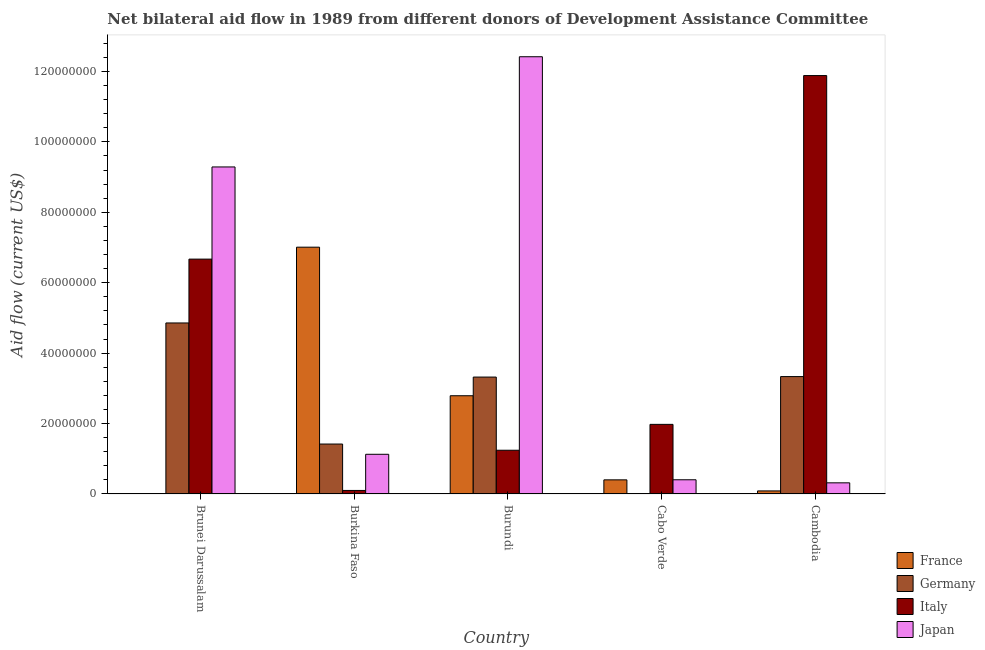Are the number of bars per tick equal to the number of legend labels?
Ensure brevity in your answer.  Yes. Are the number of bars on each tick of the X-axis equal?
Your response must be concise. Yes. What is the label of the 5th group of bars from the left?
Provide a succinct answer. Cambodia. In how many cases, is the number of bars for a given country not equal to the number of legend labels?
Keep it short and to the point. 0. What is the amount of aid given by japan in Cabo Verde?
Your answer should be compact. 4.03e+06. Across all countries, what is the maximum amount of aid given by germany?
Provide a succinct answer. 4.86e+07. Across all countries, what is the minimum amount of aid given by japan?
Offer a terse response. 3.16e+06. In which country was the amount of aid given by france maximum?
Your response must be concise. Burkina Faso. In which country was the amount of aid given by germany minimum?
Keep it short and to the point. Cabo Verde. What is the total amount of aid given by japan in the graph?
Give a very brief answer. 2.36e+08. What is the difference between the amount of aid given by germany in Brunei Darussalam and that in Burkina Faso?
Make the answer very short. 3.44e+07. What is the difference between the amount of aid given by france in Brunei Darussalam and the amount of aid given by italy in Burkina Faso?
Provide a short and direct response. -8.70e+05. What is the average amount of aid given by japan per country?
Your answer should be compact. 4.71e+07. What is the difference between the amount of aid given by france and amount of aid given by germany in Cabo Verde?
Ensure brevity in your answer.  3.97e+06. In how many countries, is the amount of aid given by japan greater than 124000000 US$?
Your answer should be compact. 1. What is the ratio of the amount of aid given by france in Burkina Faso to that in Burundi?
Make the answer very short. 2.51. Is the amount of aid given by italy in Brunei Darussalam less than that in Burundi?
Keep it short and to the point. No. What is the difference between the highest and the second highest amount of aid given by germany?
Give a very brief answer. 1.52e+07. What is the difference between the highest and the lowest amount of aid given by france?
Provide a succinct answer. 7.00e+07. In how many countries, is the amount of aid given by germany greater than the average amount of aid given by germany taken over all countries?
Offer a terse response. 3. Is it the case that in every country, the sum of the amount of aid given by italy and amount of aid given by japan is greater than the sum of amount of aid given by germany and amount of aid given by france?
Provide a succinct answer. Yes. What does the 3rd bar from the left in Burundi represents?
Make the answer very short. Italy. What does the 2nd bar from the right in Burundi represents?
Provide a short and direct response. Italy. Is it the case that in every country, the sum of the amount of aid given by france and amount of aid given by germany is greater than the amount of aid given by italy?
Make the answer very short. No. How many bars are there?
Provide a short and direct response. 20. What is the difference between two consecutive major ticks on the Y-axis?
Provide a short and direct response. 2.00e+07. Are the values on the major ticks of Y-axis written in scientific E-notation?
Give a very brief answer. No. Does the graph contain any zero values?
Provide a short and direct response. No. Where does the legend appear in the graph?
Your answer should be very brief. Bottom right. What is the title of the graph?
Offer a terse response. Net bilateral aid flow in 1989 from different donors of Development Assistance Committee. What is the label or title of the X-axis?
Your answer should be very brief. Country. What is the label or title of the Y-axis?
Give a very brief answer. Aid flow (current US$). What is the Aid flow (current US$) of France in Brunei Darussalam?
Provide a succinct answer. 1.30e+05. What is the Aid flow (current US$) in Germany in Brunei Darussalam?
Your response must be concise. 4.86e+07. What is the Aid flow (current US$) of Italy in Brunei Darussalam?
Give a very brief answer. 6.67e+07. What is the Aid flow (current US$) in Japan in Brunei Darussalam?
Provide a short and direct response. 9.29e+07. What is the Aid flow (current US$) in France in Burkina Faso?
Your answer should be compact. 7.01e+07. What is the Aid flow (current US$) of Germany in Burkina Faso?
Your answer should be compact. 1.42e+07. What is the Aid flow (current US$) of Japan in Burkina Faso?
Offer a very short reply. 1.13e+07. What is the Aid flow (current US$) of France in Burundi?
Keep it short and to the point. 2.79e+07. What is the Aid flow (current US$) of Germany in Burundi?
Give a very brief answer. 3.32e+07. What is the Aid flow (current US$) of Italy in Burundi?
Make the answer very short. 1.24e+07. What is the Aid flow (current US$) in Japan in Burundi?
Keep it short and to the point. 1.24e+08. What is the Aid flow (current US$) of France in Cabo Verde?
Offer a terse response. 4.01e+06. What is the Aid flow (current US$) of Germany in Cabo Verde?
Your answer should be very brief. 4.00e+04. What is the Aid flow (current US$) of Italy in Cabo Verde?
Provide a succinct answer. 1.98e+07. What is the Aid flow (current US$) of Japan in Cabo Verde?
Your response must be concise. 4.03e+06. What is the Aid flow (current US$) in France in Cambodia?
Make the answer very short. 8.70e+05. What is the Aid flow (current US$) in Germany in Cambodia?
Your response must be concise. 3.33e+07. What is the Aid flow (current US$) of Italy in Cambodia?
Ensure brevity in your answer.  1.19e+08. What is the Aid flow (current US$) in Japan in Cambodia?
Offer a very short reply. 3.16e+06. Across all countries, what is the maximum Aid flow (current US$) of France?
Provide a short and direct response. 7.01e+07. Across all countries, what is the maximum Aid flow (current US$) of Germany?
Ensure brevity in your answer.  4.86e+07. Across all countries, what is the maximum Aid flow (current US$) of Italy?
Give a very brief answer. 1.19e+08. Across all countries, what is the maximum Aid flow (current US$) in Japan?
Keep it short and to the point. 1.24e+08. Across all countries, what is the minimum Aid flow (current US$) in Germany?
Provide a succinct answer. 4.00e+04. Across all countries, what is the minimum Aid flow (current US$) of Italy?
Provide a short and direct response. 1.00e+06. Across all countries, what is the minimum Aid flow (current US$) of Japan?
Offer a terse response. 3.16e+06. What is the total Aid flow (current US$) of France in the graph?
Keep it short and to the point. 1.03e+08. What is the total Aid flow (current US$) in Germany in the graph?
Keep it short and to the point. 1.29e+08. What is the total Aid flow (current US$) of Italy in the graph?
Offer a terse response. 2.19e+08. What is the total Aid flow (current US$) in Japan in the graph?
Keep it short and to the point. 2.36e+08. What is the difference between the Aid flow (current US$) in France in Brunei Darussalam and that in Burkina Faso?
Give a very brief answer. -7.00e+07. What is the difference between the Aid flow (current US$) in Germany in Brunei Darussalam and that in Burkina Faso?
Keep it short and to the point. 3.44e+07. What is the difference between the Aid flow (current US$) of Italy in Brunei Darussalam and that in Burkina Faso?
Your answer should be compact. 6.57e+07. What is the difference between the Aid flow (current US$) of Japan in Brunei Darussalam and that in Burkina Faso?
Keep it short and to the point. 8.16e+07. What is the difference between the Aid flow (current US$) in France in Brunei Darussalam and that in Burundi?
Your answer should be compact. -2.78e+07. What is the difference between the Aid flow (current US$) of Germany in Brunei Darussalam and that in Burundi?
Your response must be concise. 1.54e+07. What is the difference between the Aid flow (current US$) of Italy in Brunei Darussalam and that in Burundi?
Ensure brevity in your answer.  5.43e+07. What is the difference between the Aid flow (current US$) of Japan in Brunei Darussalam and that in Burundi?
Make the answer very short. -3.13e+07. What is the difference between the Aid flow (current US$) in France in Brunei Darussalam and that in Cabo Verde?
Offer a terse response. -3.88e+06. What is the difference between the Aid flow (current US$) in Germany in Brunei Darussalam and that in Cabo Verde?
Offer a very short reply. 4.85e+07. What is the difference between the Aid flow (current US$) of Italy in Brunei Darussalam and that in Cabo Verde?
Keep it short and to the point. 4.69e+07. What is the difference between the Aid flow (current US$) in Japan in Brunei Darussalam and that in Cabo Verde?
Offer a very short reply. 8.88e+07. What is the difference between the Aid flow (current US$) of France in Brunei Darussalam and that in Cambodia?
Your response must be concise. -7.40e+05. What is the difference between the Aid flow (current US$) in Germany in Brunei Darussalam and that in Cambodia?
Provide a succinct answer. 1.52e+07. What is the difference between the Aid flow (current US$) in Italy in Brunei Darussalam and that in Cambodia?
Make the answer very short. -5.21e+07. What is the difference between the Aid flow (current US$) in Japan in Brunei Darussalam and that in Cambodia?
Your response must be concise. 8.97e+07. What is the difference between the Aid flow (current US$) in France in Burkina Faso and that in Burundi?
Make the answer very short. 4.22e+07. What is the difference between the Aid flow (current US$) of Germany in Burkina Faso and that in Burundi?
Give a very brief answer. -1.90e+07. What is the difference between the Aid flow (current US$) of Italy in Burkina Faso and that in Burundi?
Provide a short and direct response. -1.14e+07. What is the difference between the Aid flow (current US$) of Japan in Burkina Faso and that in Burundi?
Ensure brevity in your answer.  -1.13e+08. What is the difference between the Aid flow (current US$) in France in Burkina Faso and that in Cabo Verde?
Provide a short and direct response. 6.61e+07. What is the difference between the Aid flow (current US$) in Germany in Burkina Faso and that in Cabo Verde?
Give a very brief answer. 1.41e+07. What is the difference between the Aid flow (current US$) of Italy in Burkina Faso and that in Cabo Verde?
Offer a very short reply. -1.88e+07. What is the difference between the Aid flow (current US$) of Japan in Burkina Faso and that in Cabo Verde?
Give a very brief answer. 7.24e+06. What is the difference between the Aid flow (current US$) of France in Burkina Faso and that in Cambodia?
Offer a terse response. 6.92e+07. What is the difference between the Aid flow (current US$) in Germany in Burkina Faso and that in Cambodia?
Make the answer very short. -1.92e+07. What is the difference between the Aid flow (current US$) in Italy in Burkina Faso and that in Cambodia?
Offer a very short reply. -1.18e+08. What is the difference between the Aid flow (current US$) of Japan in Burkina Faso and that in Cambodia?
Provide a succinct answer. 8.11e+06. What is the difference between the Aid flow (current US$) of France in Burundi and that in Cabo Verde?
Ensure brevity in your answer.  2.39e+07. What is the difference between the Aid flow (current US$) in Germany in Burundi and that in Cabo Verde?
Your response must be concise. 3.32e+07. What is the difference between the Aid flow (current US$) of Italy in Burundi and that in Cabo Verde?
Your answer should be very brief. -7.35e+06. What is the difference between the Aid flow (current US$) of Japan in Burundi and that in Cabo Verde?
Provide a succinct answer. 1.20e+08. What is the difference between the Aid flow (current US$) of France in Burundi and that in Cambodia?
Make the answer very short. 2.70e+07. What is the difference between the Aid flow (current US$) of Italy in Burundi and that in Cambodia?
Make the answer very short. -1.06e+08. What is the difference between the Aid flow (current US$) of Japan in Burundi and that in Cambodia?
Provide a succinct answer. 1.21e+08. What is the difference between the Aid flow (current US$) of France in Cabo Verde and that in Cambodia?
Ensure brevity in your answer.  3.14e+06. What is the difference between the Aid flow (current US$) of Germany in Cabo Verde and that in Cambodia?
Ensure brevity in your answer.  -3.33e+07. What is the difference between the Aid flow (current US$) of Italy in Cabo Verde and that in Cambodia?
Offer a terse response. -9.91e+07. What is the difference between the Aid flow (current US$) in Japan in Cabo Verde and that in Cambodia?
Provide a succinct answer. 8.70e+05. What is the difference between the Aid flow (current US$) of France in Brunei Darussalam and the Aid flow (current US$) of Germany in Burkina Faso?
Offer a terse response. -1.40e+07. What is the difference between the Aid flow (current US$) in France in Brunei Darussalam and the Aid flow (current US$) in Italy in Burkina Faso?
Offer a terse response. -8.70e+05. What is the difference between the Aid flow (current US$) in France in Brunei Darussalam and the Aid flow (current US$) in Japan in Burkina Faso?
Offer a terse response. -1.11e+07. What is the difference between the Aid flow (current US$) in Germany in Brunei Darussalam and the Aid flow (current US$) in Italy in Burkina Faso?
Keep it short and to the point. 4.76e+07. What is the difference between the Aid flow (current US$) in Germany in Brunei Darussalam and the Aid flow (current US$) in Japan in Burkina Faso?
Your answer should be very brief. 3.73e+07. What is the difference between the Aid flow (current US$) of Italy in Brunei Darussalam and the Aid flow (current US$) of Japan in Burkina Faso?
Ensure brevity in your answer.  5.54e+07. What is the difference between the Aid flow (current US$) in France in Brunei Darussalam and the Aid flow (current US$) in Germany in Burundi?
Give a very brief answer. -3.31e+07. What is the difference between the Aid flow (current US$) of France in Brunei Darussalam and the Aid flow (current US$) of Italy in Burundi?
Offer a very short reply. -1.23e+07. What is the difference between the Aid flow (current US$) of France in Brunei Darussalam and the Aid flow (current US$) of Japan in Burundi?
Keep it short and to the point. -1.24e+08. What is the difference between the Aid flow (current US$) of Germany in Brunei Darussalam and the Aid flow (current US$) of Italy in Burundi?
Provide a short and direct response. 3.62e+07. What is the difference between the Aid flow (current US$) of Germany in Brunei Darussalam and the Aid flow (current US$) of Japan in Burundi?
Keep it short and to the point. -7.56e+07. What is the difference between the Aid flow (current US$) of Italy in Brunei Darussalam and the Aid flow (current US$) of Japan in Burundi?
Give a very brief answer. -5.75e+07. What is the difference between the Aid flow (current US$) in France in Brunei Darussalam and the Aid flow (current US$) in Italy in Cabo Verde?
Keep it short and to the point. -1.96e+07. What is the difference between the Aid flow (current US$) in France in Brunei Darussalam and the Aid flow (current US$) in Japan in Cabo Verde?
Ensure brevity in your answer.  -3.90e+06. What is the difference between the Aid flow (current US$) of Germany in Brunei Darussalam and the Aid flow (current US$) of Italy in Cabo Verde?
Keep it short and to the point. 2.88e+07. What is the difference between the Aid flow (current US$) in Germany in Brunei Darussalam and the Aid flow (current US$) in Japan in Cabo Verde?
Keep it short and to the point. 4.45e+07. What is the difference between the Aid flow (current US$) in Italy in Brunei Darussalam and the Aid flow (current US$) in Japan in Cabo Verde?
Give a very brief answer. 6.27e+07. What is the difference between the Aid flow (current US$) of France in Brunei Darussalam and the Aid flow (current US$) of Germany in Cambodia?
Your response must be concise. -3.32e+07. What is the difference between the Aid flow (current US$) of France in Brunei Darussalam and the Aid flow (current US$) of Italy in Cambodia?
Provide a short and direct response. -1.19e+08. What is the difference between the Aid flow (current US$) in France in Brunei Darussalam and the Aid flow (current US$) in Japan in Cambodia?
Your answer should be very brief. -3.03e+06. What is the difference between the Aid flow (current US$) of Germany in Brunei Darussalam and the Aid flow (current US$) of Italy in Cambodia?
Your response must be concise. -7.03e+07. What is the difference between the Aid flow (current US$) in Germany in Brunei Darussalam and the Aid flow (current US$) in Japan in Cambodia?
Keep it short and to the point. 4.54e+07. What is the difference between the Aid flow (current US$) of Italy in Brunei Darussalam and the Aid flow (current US$) of Japan in Cambodia?
Your response must be concise. 6.35e+07. What is the difference between the Aid flow (current US$) in France in Burkina Faso and the Aid flow (current US$) in Germany in Burundi?
Provide a short and direct response. 3.69e+07. What is the difference between the Aid flow (current US$) in France in Burkina Faso and the Aid flow (current US$) in Italy in Burundi?
Your answer should be compact. 5.77e+07. What is the difference between the Aid flow (current US$) in France in Burkina Faso and the Aid flow (current US$) in Japan in Burundi?
Provide a succinct answer. -5.41e+07. What is the difference between the Aid flow (current US$) of Germany in Burkina Faso and the Aid flow (current US$) of Italy in Burundi?
Provide a short and direct response. 1.76e+06. What is the difference between the Aid flow (current US$) in Germany in Burkina Faso and the Aid flow (current US$) in Japan in Burundi?
Your answer should be very brief. -1.10e+08. What is the difference between the Aid flow (current US$) of Italy in Burkina Faso and the Aid flow (current US$) of Japan in Burundi?
Keep it short and to the point. -1.23e+08. What is the difference between the Aid flow (current US$) in France in Burkina Faso and the Aid flow (current US$) in Germany in Cabo Verde?
Your response must be concise. 7.00e+07. What is the difference between the Aid flow (current US$) of France in Burkina Faso and the Aid flow (current US$) of Italy in Cabo Verde?
Keep it short and to the point. 5.03e+07. What is the difference between the Aid flow (current US$) in France in Burkina Faso and the Aid flow (current US$) in Japan in Cabo Verde?
Your response must be concise. 6.61e+07. What is the difference between the Aid flow (current US$) of Germany in Burkina Faso and the Aid flow (current US$) of Italy in Cabo Verde?
Keep it short and to the point. -5.59e+06. What is the difference between the Aid flow (current US$) in Germany in Burkina Faso and the Aid flow (current US$) in Japan in Cabo Verde?
Offer a very short reply. 1.02e+07. What is the difference between the Aid flow (current US$) of Italy in Burkina Faso and the Aid flow (current US$) of Japan in Cabo Verde?
Offer a terse response. -3.03e+06. What is the difference between the Aid flow (current US$) of France in Burkina Faso and the Aid flow (current US$) of Germany in Cambodia?
Offer a terse response. 3.68e+07. What is the difference between the Aid flow (current US$) in France in Burkina Faso and the Aid flow (current US$) in Italy in Cambodia?
Make the answer very short. -4.87e+07. What is the difference between the Aid flow (current US$) in France in Burkina Faso and the Aid flow (current US$) in Japan in Cambodia?
Give a very brief answer. 6.69e+07. What is the difference between the Aid flow (current US$) in Germany in Burkina Faso and the Aid flow (current US$) in Italy in Cambodia?
Offer a very short reply. -1.05e+08. What is the difference between the Aid flow (current US$) of Germany in Burkina Faso and the Aid flow (current US$) of Japan in Cambodia?
Your answer should be very brief. 1.10e+07. What is the difference between the Aid flow (current US$) in Italy in Burkina Faso and the Aid flow (current US$) in Japan in Cambodia?
Keep it short and to the point. -2.16e+06. What is the difference between the Aid flow (current US$) in France in Burundi and the Aid flow (current US$) in Germany in Cabo Verde?
Provide a short and direct response. 2.79e+07. What is the difference between the Aid flow (current US$) in France in Burundi and the Aid flow (current US$) in Italy in Cabo Verde?
Keep it short and to the point. 8.13e+06. What is the difference between the Aid flow (current US$) of France in Burundi and the Aid flow (current US$) of Japan in Cabo Verde?
Keep it short and to the point. 2.39e+07. What is the difference between the Aid flow (current US$) of Germany in Burundi and the Aid flow (current US$) of Italy in Cabo Verde?
Your response must be concise. 1.34e+07. What is the difference between the Aid flow (current US$) of Germany in Burundi and the Aid flow (current US$) of Japan in Cabo Verde?
Give a very brief answer. 2.92e+07. What is the difference between the Aid flow (current US$) of Italy in Burundi and the Aid flow (current US$) of Japan in Cabo Verde?
Give a very brief answer. 8.39e+06. What is the difference between the Aid flow (current US$) of France in Burundi and the Aid flow (current US$) of Germany in Cambodia?
Ensure brevity in your answer.  -5.44e+06. What is the difference between the Aid flow (current US$) of France in Burundi and the Aid flow (current US$) of Italy in Cambodia?
Provide a short and direct response. -9.09e+07. What is the difference between the Aid flow (current US$) of France in Burundi and the Aid flow (current US$) of Japan in Cambodia?
Your answer should be very brief. 2.47e+07. What is the difference between the Aid flow (current US$) in Germany in Burundi and the Aid flow (current US$) in Italy in Cambodia?
Give a very brief answer. -8.56e+07. What is the difference between the Aid flow (current US$) of Germany in Burundi and the Aid flow (current US$) of Japan in Cambodia?
Offer a terse response. 3.00e+07. What is the difference between the Aid flow (current US$) of Italy in Burundi and the Aid flow (current US$) of Japan in Cambodia?
Provide a succinct answer. 9.26e+06. What is the difference between the Aid flow (current US$) in France in Cabo Verde and the Aid flow (current US$) in Germany in Cambodia?
Provide a succinct answer. -2.93e+07. What is the difference between the Aid flow (current US$) of France in Cabo Verde and the Aid flow (current US$) of Italy in Cambodia?
Your response must be concise. -1.15e+08. What is the difference between the Aid flow (current US$) in France in Cabo Verde and the Aid flow (current US$) in Japan in Cambodia?
Your answer should be very brief. 8.50e+05. What is the difference between the Aid flow (current US$) in Germany in Cabo Verde and the Aid flow (current US$) in Italy in Cambodia?
Ensure brevity in your answer.  -1.19e+08. What is the difference between the Aid flow (current US$) in Germany in Cabo Verde and the Aid flow (current US$) in Japan in Cambodia?
Ensure brevity in your answer.  -3.12e+06. What is the difference between the Aid flow (current US$) in Italy in Cabo Verde and the Aid flow (current US$) in Japan in Cambodia?
Offer a terse response. 1.66e+07. What is the average Aid flow (current US$) in France per country?
Offer a very short reply. 2.06e+07. What is the average Aid flow (current US$) of Germany per country?
Provide a succinct answer. 2.59e+07. What is the average Aid flow (current US$) in Italy per country?
Make the answer very short. 4.37e+07. What is the average Aid flow (current US$) in Japan per country?
Your answer should be very brief. 4.71e+07. What is the difference between the Aid flow (current US$) of France and Aid flow (current US$) of Germany in Brunei Darussalam?
Offer a very short reply. -4.84e+07. What is the difference between the Aid flow (current US$) in France and Aid flow (current US$) in Italy in Brunei Darussalam?
Provide a succinct answer. -6.66e+07. What is the difference between the Aid flow (current US$) in France and Aid flow (current US$) in Japan in Brunei Darussalam?
Ensure brevity in your answer.  -9.28e+07. What is the difference between the Aid flow (current US$) in Germany and Aid flow (current US$) in Italy in Brunei Darussalam?
Keep it short and to the point. -1.81e+07. What is the difference between the Aid flow (current US$) of Germany and Aid flow (current US$) of Japan in Brunei Darussalam?
Provide a succinct answer. -4.43e+07. What is the difference between the Aid flow (current US$) in Italy and Aid flow (current US$) in Japan in Brunei Darussalam?
Give a very brief answer. -2.62e+07. What is the difference between the Aid flow (current US$) of France and Aid flow (current US$) of Germany in Burkina Faso?
Give a very brief answer. 5.59e+07. What is the difference between the Aid flow (current US$) in France and Aid flow (current US$) in Italy in Burkina Faso?
Give a very brief answer. 6.91e+07. What is the difference between the Aid flow (current US$) in France and Aid flow (current US$) in Japan in Burkina Faso?
Your answer should be very brief. 5.88e+07. What is the difference between the Aid flow (current US$) of Germany and Aid flow (current US$) of Italy in Burkina Faso?
Offer a terse response. 1.32e+07. What is the difference between the Aid flow (current US$) of Germany and Aid flow (current US$) of Japan in Burkina Faso?
Provide a succinct answer. 2.91e+06. What is the difference between the Aid flow (current US$) in Italy and Aid flow (current US$) in Japan in Burkina Faso?
Your answer should be compact. -1.03e+07. What is the difference between the Aid flow (current US$) in France and Aid flow (current US$) in Germany in Burundi?
Your response must be concise. -5.30e+06. What is the difference between the Aid flow (current US$) of France and Aid flow (current US$) of Italy in Burundi?
Give a very brief answer. 1.55e+07. What is the difference between the Aid flow (current US$) of France and Aid flow (current US$) of Japan in Burundi?
Your answer should be very brief. -9.63e+07. What is the difference between the Aid flow (current US$) in Germany and Aid flow (current US$) in Italy in Burundi?
Give a very brief answer. 2.08e+07. What is the difference between the Aid flow (current US$) of Germany and Aid flow (current US$) of Japan in Burundi?
Provide a succinct answer. -9.10e+07. What is the difference between the Aid flow (current US$) in Italy and Aid flow (current US$) in Japan in Burundi?
Offer a very short reply. -1.12e+08. What is the difference between the Aid flow (current US$) in France and Aid flow (current US$) in Germany in Cabo Verde?
Your answer should be very brief. 3.97e+06. What is the difference between the Aid flow (current US$) of France and Aid flow (current US$) of Italy in Cabo Verde?
Offer a terse response. -1.58e+07. What is the difference between the Aid flow (current US$) in Germany and Aid flow (current US$) in Italy in Cabo Verde?
Offer a terse response. -1.97e+07. What is the difference between the Aid flow (current US$) in Germany and Aid flow (current US$) in Japan in Cabo Verde?
Offer a very short reply. -3.99e+06. What is the difference between the Aid flow (current US$) in Italy and Aid flow (current US$) in Japan in Cabo Verde?
Give a very brief answer. 1.57e+07. What is the difference between the Aid flow (current US$) of France and Aid flow (current US$) of Germany in Cambodia?
Your answer should be very brief. -3.25e+07. What is the difference between the Aid flow (current US$) of France and Aid flow (current US$) of Italy in Cambodia?
Your response must be concise. -1.18e+08. What is the difference between the Aid flow (current US$) in France and Aid flow (current US$) in Japan in Cambodia?
Give a very brief answer. -2.29e+06. What is the difference between the Aid flow (current US$) of Germany and Aid flow (current US$) of Italy in Cambodia?
Keep it short and to the point. -8.55e+07. What is the difference between the Aid flow (current US$) in Germany and Aid flow (current US$) in Japan in Cambodia?
Offer a very short reply. 3.02e+07. What is the difference between the Aid flow (current US$) in Italy and Aid flow (current US$) in Japan in Cambodia?
Keep it short and to the point. 1.16e+08. What is the ratio of the Aid flow (current US$) of France in Brunei Darussalam to that in Burkina Faso?
Keep it short and to the point. 0. What is the ratio of the Aid flow (current US$) in Germany in Brunei Darussalam to that in Burkina Faso?
Make the answer very short. 3.43. What is the ratio of the Aid flow (current US$) of Italy in Brunei Darussalam to that in Burkina Faso?
Provide a succinct answer. 66.7. What is the ratio of the Aid flow (current US$) in Japan in Brunei Darussalam to that in Burkina Faso?
Offer a terse response. 8.24. What is the ratio of the Aid flow (current US$) in France in Brunei Darussalam to that in Burundi?
Your response must be concise. 0. What is the ratio of the Aid flow (current US$) of Germany in Brunei Darussalam to that in Burundi?
Give a very brief answer. 1.46. What is the ratio of the Aid flow (current US$) of Italy in Brunei Darussalam to that in Burundi?
Make the answer very short. 5.37. What is the ratio of the Aid flow (current US$) in Japan in Brunei Darussalam to that in Burundi?
Your answer should be compact. 0.75. What is the ratio of the Aid flow (current US$) of France in Brunei Darussalam to that in Cabo Verde?
Offer a very short reply. 0.03. What is the ratio of the Aid flow (current US$) of Germany in Brunei Darussalam to that in Cabo Verde?
Offer a terse response. 1214.25. What is the ratio of the Aid flow (current US$) in Italy in Brunei Darussalam to that in Cabo Verde?
Ensure brevity in your answer.  3.37. What is the ratio of the Aid flow (current US$) of Japan in Brunei Darussalam to that in Cabo Verde?
Provide a short and direct response. 23.05. What is the ratio of the Aid flow (current US$) of France in Brunei Darussalam to that in Cambodia?
Give a very brief answer. 0.15. What is the ratio of the Aid flow (current US$) of Germany in Brunei Darussalam to that in Cambodia?
Ensure brevity in your answer.  1.46. What is the ratio of the Aid flow (current US$) of Italy in Brunei Darussalam to that in Cambodia?
Keep it short and to the point. 0.56. What is the ratio of the Aid flow (current US$) in Japan in Brunei Darussalam to that in Cambodia?
Your answer should be compact. 29.39. What is the ratio of the Aid flow (current US$) of France in Burkina Faso to that in Burundi?
Offer a terse response. 2.51. What is the ratio of the Aid flow (current US$) of Germany in Burkina Faso to that in Burundi?
Offer a terse response. 0.43. What is the ratio of the Aid flow (current US$) in Italy in Burkina Faso to that in Burundi?
Offer a very short reply. 0.08. What is the ratio of the Aid flow (current US$) in Japan in Burkina Faso to that in Burundi?
Provide a short and direct response. 0.09. What is the ratio of the Aid flow (current US$) of France in Burkina Faso to that in Cabo Verde?
Offer a very short reply. 17.48. What is the ratio of the Aid flow (current US$) of Germany in Burkina Faso to that in Cabo Verde?
Provide a short and direct response. 354.5. What is the ratio of the Aid flow (current US$) of Italy in Burkina Faso to that in Cabo Verde?
Make the answer very short. 0.05. What is the ratio of the Aid flow (current US$) of Japan in Burkina Faso to that in Cabo Verde?
Ensure brevity in your answer.  2.8. What is the ratio of the Aid flow (current US$) in France in Burkina Faso to that in Cambodia?
Provide a succinct answer. 80.56. What is the ratio of the Aid flow (current US$) in Germany in Burkina Faso to that in Cambodia?
Make the answer very short. 0.43. What is the ratio of the Aid flow (current US$) in Italy in Burkina Faso to that in Cambodia?
Your response must be concise. 0.01. What is the ratio of the Aid flow (current US$) of Japan in Burkina Faso to that in Cambodia?
Provide a succinct answer. 3.57. What is the ratio of the Aid flow (current US$) in France in Burundi to that in Cabo Verde?
Offer a terse response. 6.96. What is the ratio of the Aid flow (current US$) of Germany in Burundi to that in Cabo Verde?
Offer a very short reply. 830. What is the ratio of the Aid flow (current US$) of Italy in Burundi to that in Cabo Verde?
Your answer should be very brief. 0.63. What is the ratio of the Aid flow (current US$) of Japan in Burundi to that in Cabo Verde?
Provide a succinct answer. 30.81. What is the ratio of the Aid flow (current US$) of France in Burundi to that in Cambodia?
Give a very brief answer. 32.07. What is the ratio of the Aid flow (current US$) in Italy in Burundi to that in Cambodia?
Make the answer very short. 0.1. What is the ratio of the Aid flow (current US$) in Japan in Burundi to that in Cambodia?
Provide a short and direct response. 39.3. What is the ratio of the Aid flow (current US$) of France in Cabo Verde to that in Cambodia?
Provide a short and direct response. 4.61. What is the ratio of the Aid flow (current US$) in Germany in Cabo Verde to that in Cambodia?
Your answer should be very brief. 0. What is the ratio of the Aid flow (current US$) of Italy in Cabo Verde to that in Cambodia?
Give a very brief answer. 0.17. What is the ratio of the Aid flow (current US$) of Japan in Cabo Verde to that in Cambodia?
Ensure brevity in your answer.  1.28. What is the difference between the highest and the second highest Aid flow (current US$) of France?
Offer a terse response. 4.22e+07. What is the difference between the highest and the second highest Aid flow (current US$) of Germany?
Ensure brevity in your answer.  1.52e+07. What is the difference between the highest and the second highest Aid flow (current US$) in Italy?
Keep it short and to the point. 5.21e+07. What is the difference between the highest and the second highest Aid flow (current US$) of Japan?
Offer a terse response. 3.13e+07. What is the difference between the highest and the lowest Aid flow (current US$) in France?
Keep it short and to the point. 7.00e+07. What is the difference between the highest and the lowest Aid flow (current US$) in Germany?
Keep it short and to the point. 4.85e+07. What is the difference between the highest and the lowest Aid flow (current US$) in Italy?
Your answer should be compact. 1.18e+08. What is the difference between the highest and the lowest Aid flow (current US$) of Japan?
Offer a terse response. 1.21e+08. 